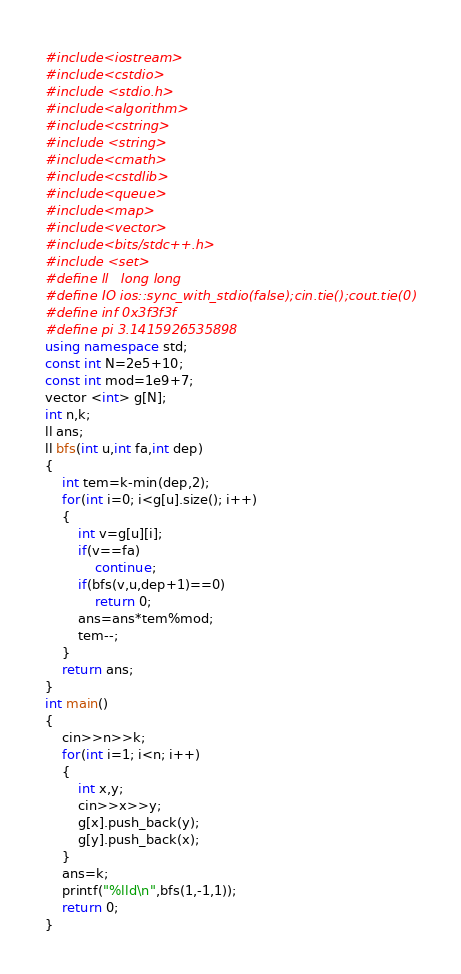Convert code to text. <code><loc_0><loc_0><loc_500><loc_500><_C++_>#include<iostream>
#include<cstdio>
#include <stdio.h>
#include<algorithm>
#include<cstring>
#include <string>
#include<cmath>
#include<cstdlib>
#include<queue>
#include<map>
#include<vector>
#include<bits/stdc++.h>
#include <set>
#define ll   long long
#define IO ios::sync_with_stdio(false);cin.tie();cout.tie(0)
#define inf 0x3f3f3f
#define pi 3.1415926535898
using namespace std;
const int N=2e5+10;
const int mod=1e9+7;
vector <int> g[N];
int n,k;
ll ans;
ll bfs(int u,int fa,int dep)
{
    int tem=k-min(dep,2);
    for(int i=0; i<g[u].size(); i++)
    {
        int v=g[u][i];
        if(v==fa)
            continue;
        if(bfs(v,u,dep+1)==0)
            return 0;
        ans=ans*tem%mod;
        tem--;
    }
    return ans;
}
int main()
{
    cin>>n>>k;
    for(int i=1; i<n; i++)
    {
        int x,y;
        cin>>x>>y;
        g[x].push_back(y);
        g[y].push_back(x);
    }
    ans=k;
    printf("%lld\n",bfs(1,-1,1));
    return 0;
}
</code> 